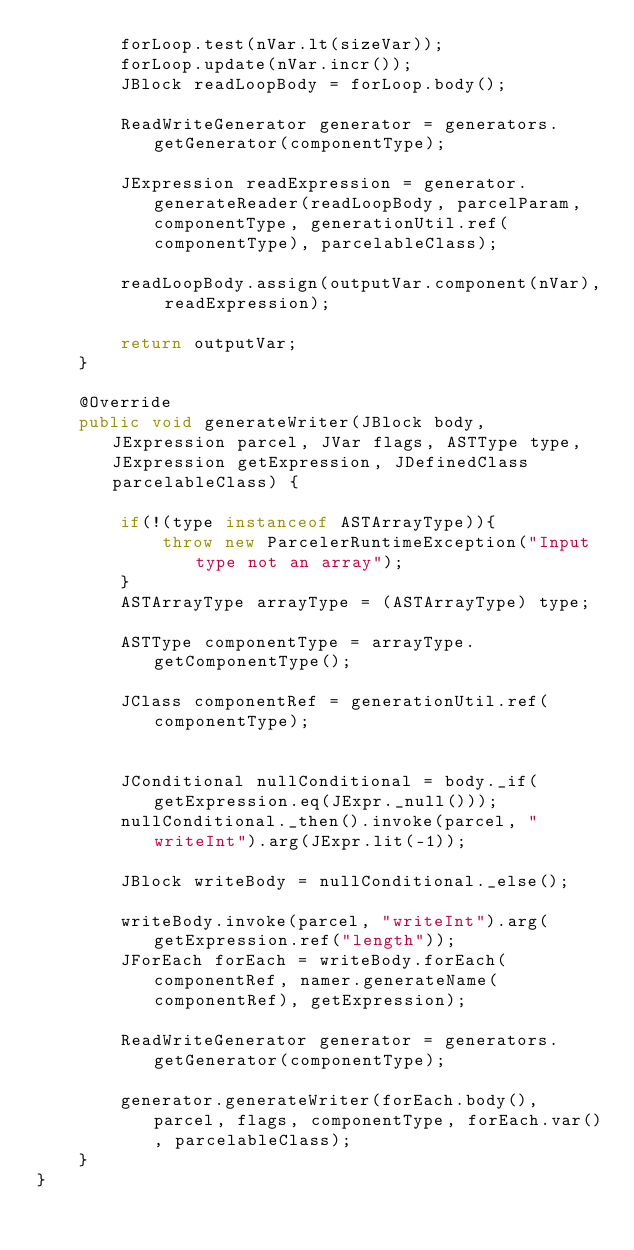<code> <loc_0><loc_0><loc_500><loc_500><_Java_>        forLoop.test(nVar.lt(sizeVar));
        forLoop.update(nVar.incr());
        JBlock readLoopBody = forLoop.body();

        ReadWriteGenerator generator = generators.getGenerator(componentType);

        JExpression readExpression = generator.generateReader(readLoopBody, parcelParam, componentType, generationUtil.ref(componentType), parcelableClass);

        readLoopBody.assign(outputVar.component(nVar), readExpression);

        return outputVar;
    }

    @Override
    public void generateWriter(JBlock body, JExpression parcel, JVar flags, ASTType type, JExpression getExpression, JDefinedClass parcelableClass) {

        if(!(type instanceof ASTArrayType)){
            throw new ParcelerRuntimeException("Input type not an array");
        }
        ASTArrayType arrayType = (ASTArrayType) type;

        ASTType componentType = arrayType.getComponentType();

        JClass componentRef = generationUtil.ref(componentType);


        JConditional nullConditional = body._if(getExpression.eq(JExpr._null()));
        nullConditional._then().invoke(parcel, "writeInt").arg(JExpr.lit(-1));

        JBlock writeBody = nullConditional._else();

        writeBody.invoke(parcel, "writeInt").arg(getExpression.ref("length"));
        JForEach forEach = writeBody.forEach(componentRef, namer.generateName(componentRef), getExpression);

        ReadWriteGenerator generator = generators.getGenerator(componentType);

        generator.generateWriter(forEach.body(), parcel, flags, componentType, forEach.var(), parcelableClass);
    }
}
</code> 